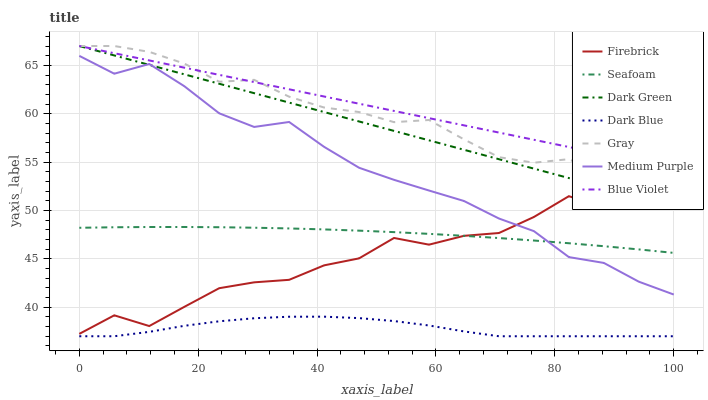Does Dark Blue have the minimum area under the curve?
Answer yes or no. Yes. Does Blue Violet have the maximum area under the curve?
Answer yes or no. Yes. Does Firebrick have the minimum area under the curve?
Answer yes or no. No. Does Firebrick have the maximum area under the curve?
Answer yes or no. No. Is Blue Violet the smoothest?
Answer yes or no. Yes. Is Firebrick the roughest?
Answer yes or no. Yes. Is Seafoam the smoothest?
Answer yes or no. No. Is Seafoam the roughest?
Answer yes or no. No. Does Dark Blue have the lowest value?
Answer yes or no. Yes. Does Firebrick have the lowest value?
Answer yes or no. No. Does Dark Green have the highest value?
Answer yes or no. Yes. Does Firebrick have the highest value?
Answer yes or no. No. Is Seafoam less than Blue Violet?
Answer yes or no. Yes. Is Gray greater than Firebrick?
Answer yes or no. Yes. Does Blue Violet intersect Dark Green?
Answer yes or no. Yes. Is Blue Violet less than Dark Green?
Answer yes or no. No. Is Blue Violet greater than Dark Green?
Answer yes or no. No. Does Seafoam intersect Blue Violet?
Answer yes or no. No. 